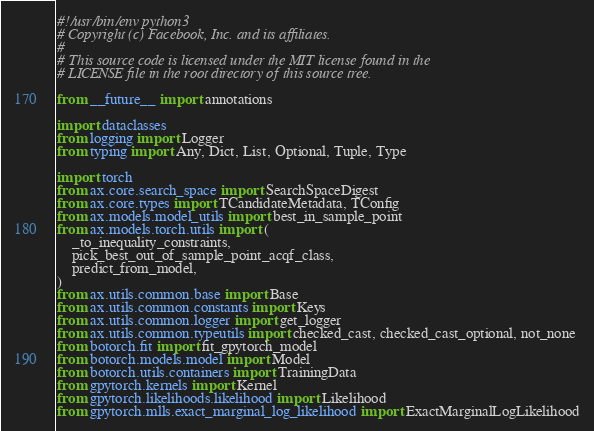Convert code to text. <code><loc_0><loc_0><loc_500><loc_500><_Python_>#!/usr/bin/env python3
# Copyright (c) Facebook, Inc. and its affiliates.
#
# This source code is licensed under the MIT license found in the
# LICENSE file in the root directory of this source tree.

from __future__ import annotations

import dataclasses
from logging import Logger
from typing import Any, Dict, List, Optional, Tuple, Type

import torch
from ax.core.search_space import SearchSpaceDigest
from ax.core.types import TCandidateMetadata, TConfig
from ax.models.model_utils import best_in_sample_point
from ax.models.torch.utils import (
    _to_inequality_constraints,
    pick_best_out_of_sample_point_acqf_class,
    predict_from_model,
)
from ax.utils.common.base import Base
from ax.utils.common.constants import Keys
from ax.utils.common.logger import get_logger
from ax.utils.common.typeutils import checked_cast, checked_cast_optional, not_none
from botorch.fit import fit_gpytorch_model
from botorch.models.model import Model
from botorch.utils.containers import TrainingData
from gpytorch.kernels import Kernel
from gpytorch.likelihoods.likelihood import Likelihood
from gpytorch.mlls.exact_marginal_log_likelihood import ExactMarginalLogLikelihood</code> 